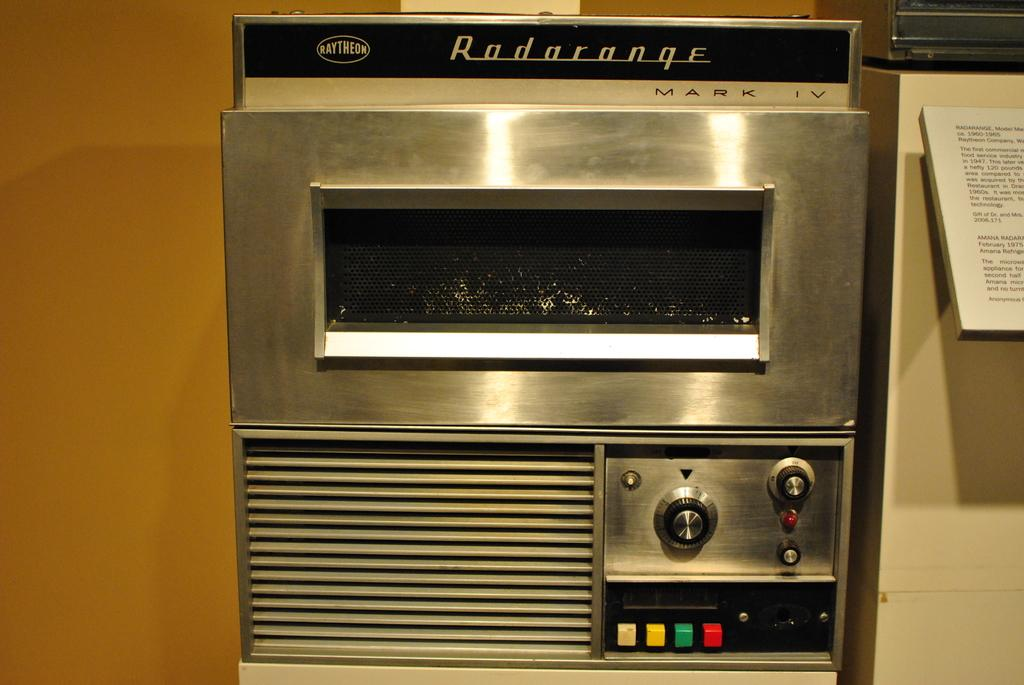<image>
Provide a brief description of the given image. The instruction manual for this Radarange oven sits to the right of it. 